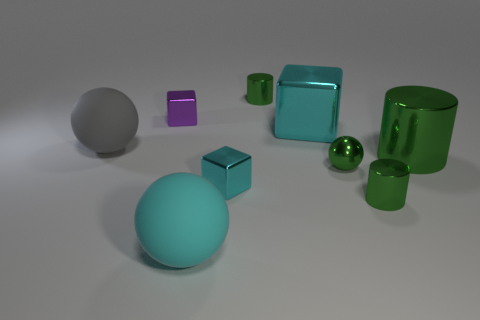Tell me about the different colors present in this assortment of objects. The objects display a range of colors, including a vivid green seen in multiple shiny objects, a distinct teal hue on the large sphere, a muted gray of the large matte ball, and a touch of purple on a small cube. The colors and their reflectivity interact with the light, giving the image a varied and colorful appearance. 